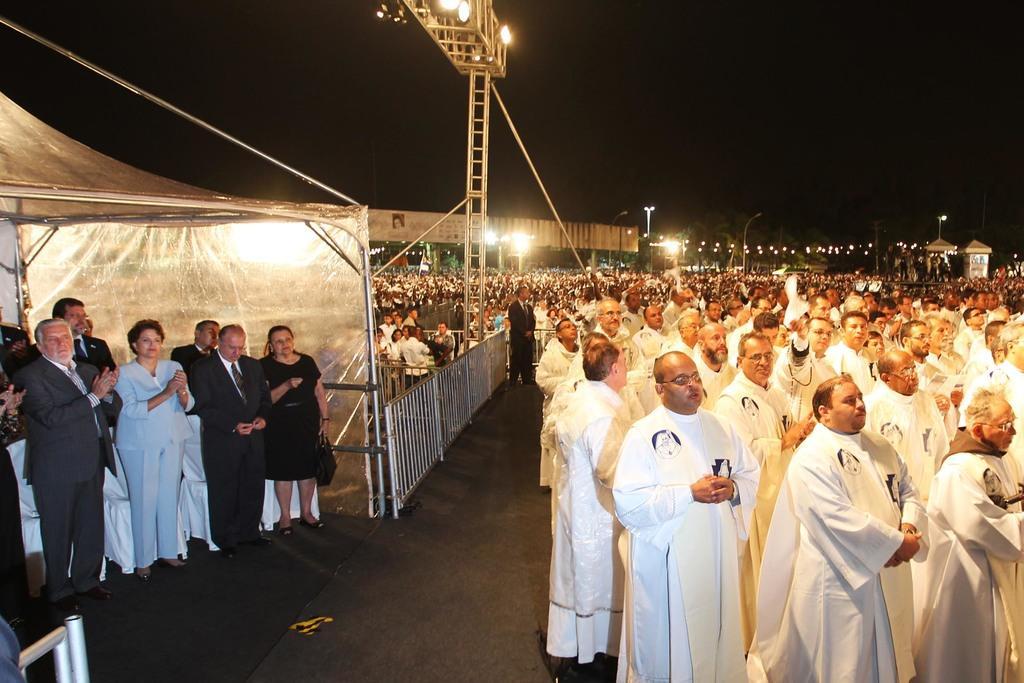Describe this image in one or two sentences. In this image we can see the people standing on the ground. And there are lights attached to the road and we can see a fence, board, street light, pillars and dark background. 